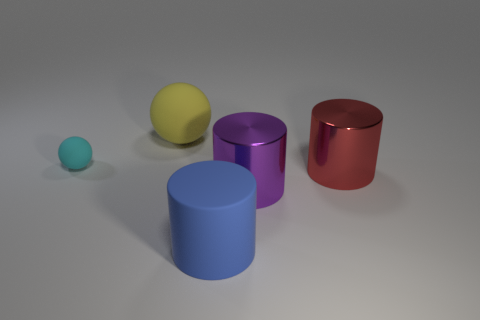Add 2 tiny cyan rubber things. How many objects exist? 7 Subtract all cylinders. How many objects are left? 2 Subtract all purple things. Subtract all large green rubber objects. How many objects are left? 4 Add 5 big red shiny objects. How many big red shiny objects are left? 6 Add 1 big yellow rubber things. How many big yellow rubber things exist? 2 Subtract 0 cyan blocks. How many objects are left? 5 